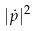<formula> <loc_0><loc_0><loc_500><loc_500>| { \dot { p } } | ^ { 2 }</formula> 